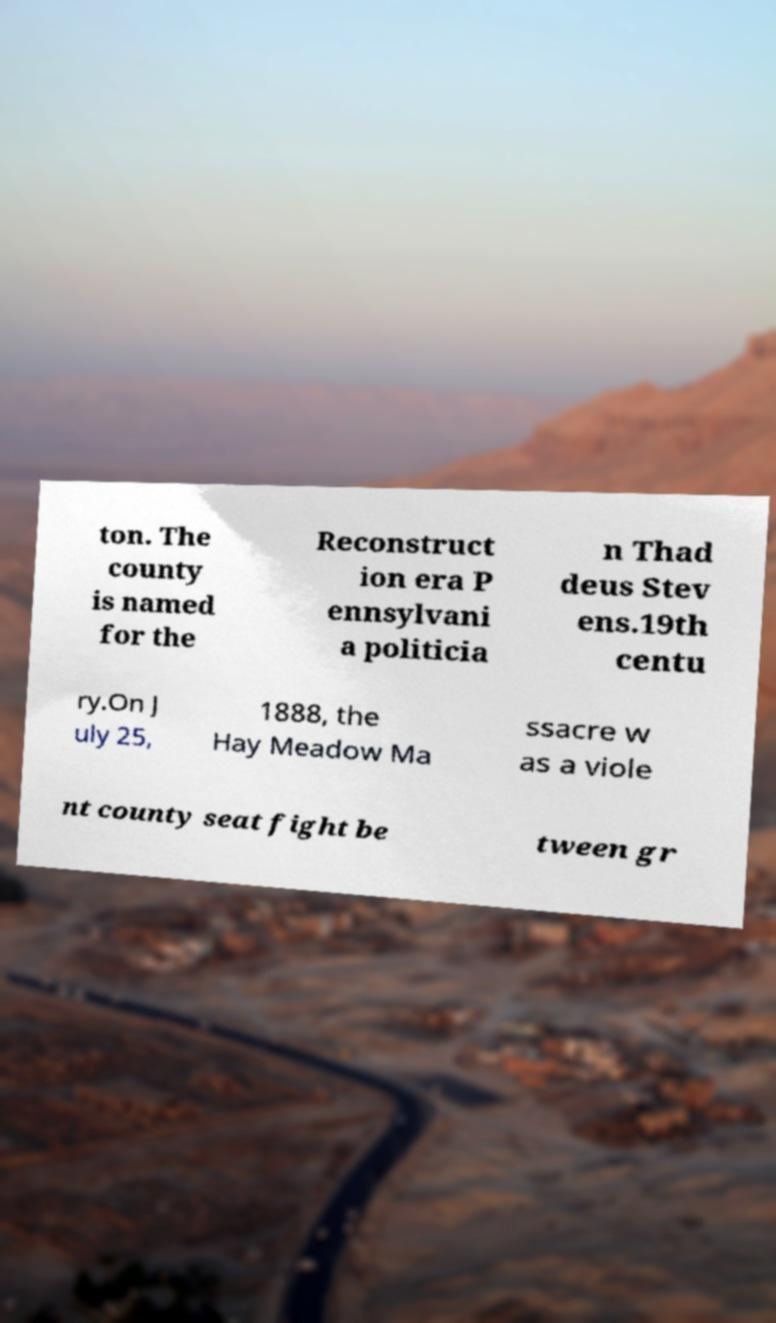I need the written content from this picture converted into text. Can you do that? ton. The county is named for the Reconstruct ion era P ennsylvani a politicia n Thad deus Stev ens.19th centu ry.On J uly 25, 1888, the Hay Meadow Ma ssacre w as a viole nt county seat fight be tween gr 